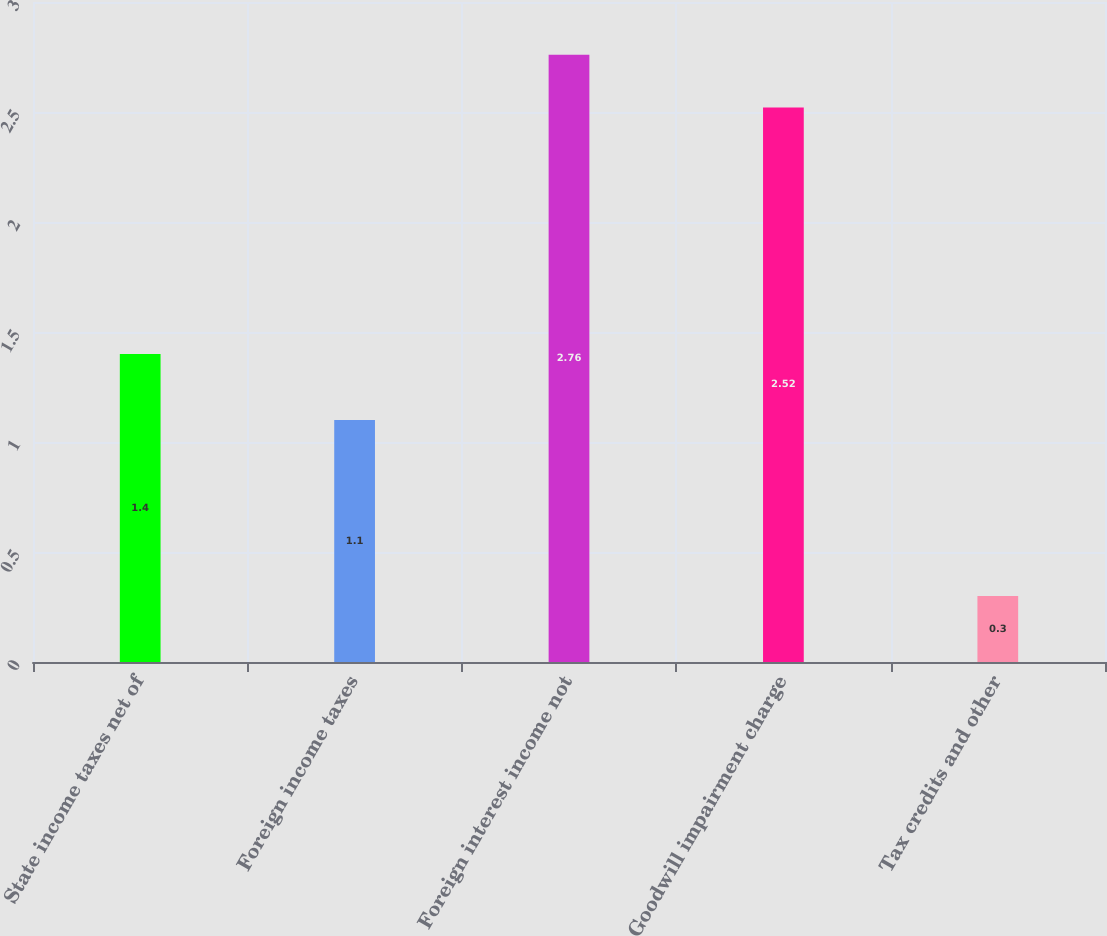Convert chart to OTSL. <chart><loc_0><loc_0><loc_500><loc_500><bar_chart><fcel>State income taxes net of<fcel>Foreign income taxes<fcel>Foreign interest income not<fcel>Goodwill impairment charge<fcel>Tax credits and other<nl><fcel>1.4<fcel>1.1<fcel>2.76<fcel>2.52<fcel>0.3<nl></chart> 